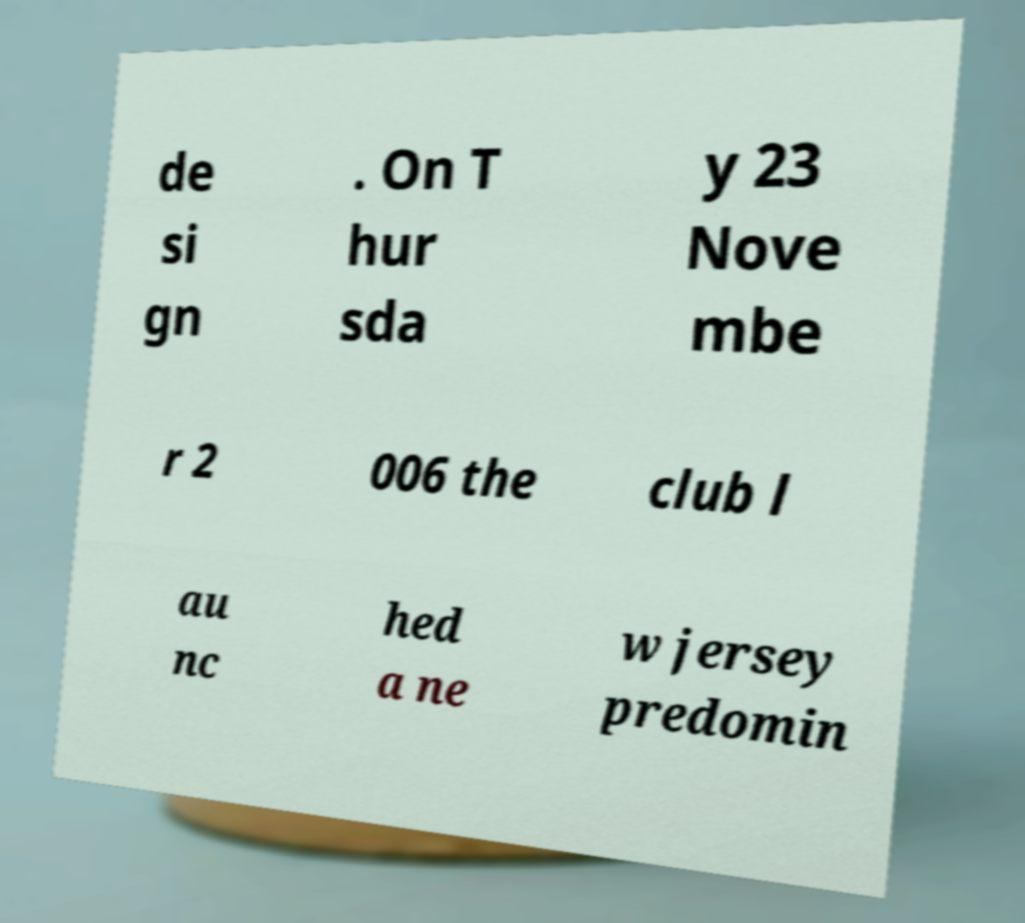Could you assist in decoding the text presented in this image and type it out clearly? de si gn . On T hur sda y 23 Nove mbe r 2 006 the club l au nc hed a ne w jersey predomin 